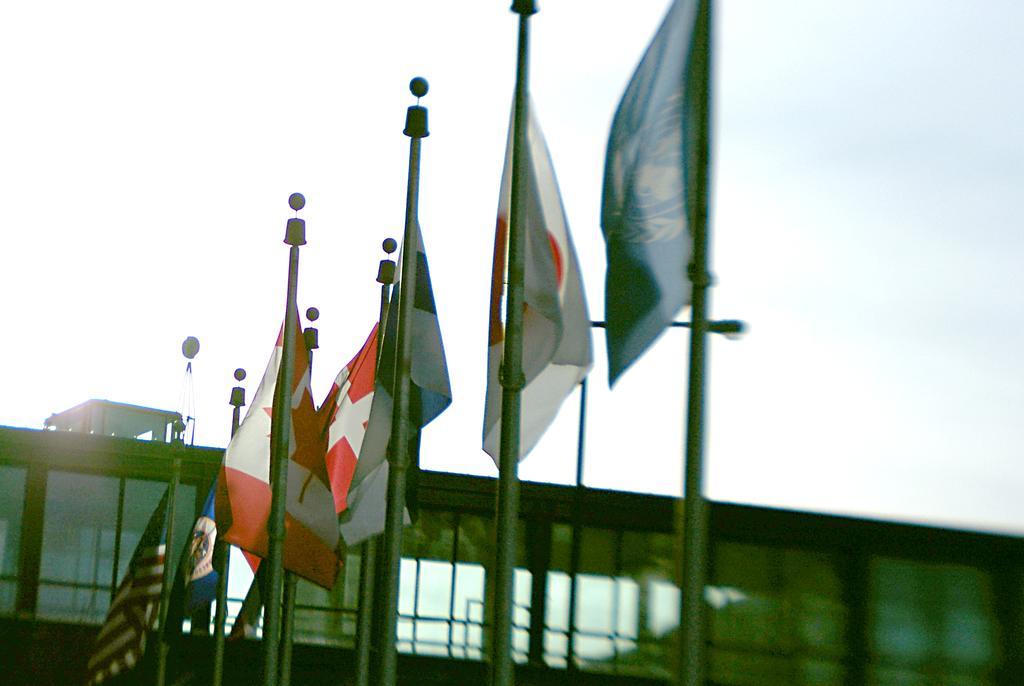Describe this image in one or two sentences. In the foreground of this image, there are flags. At the bottom background, there is a building. At the top, there is the sky. 